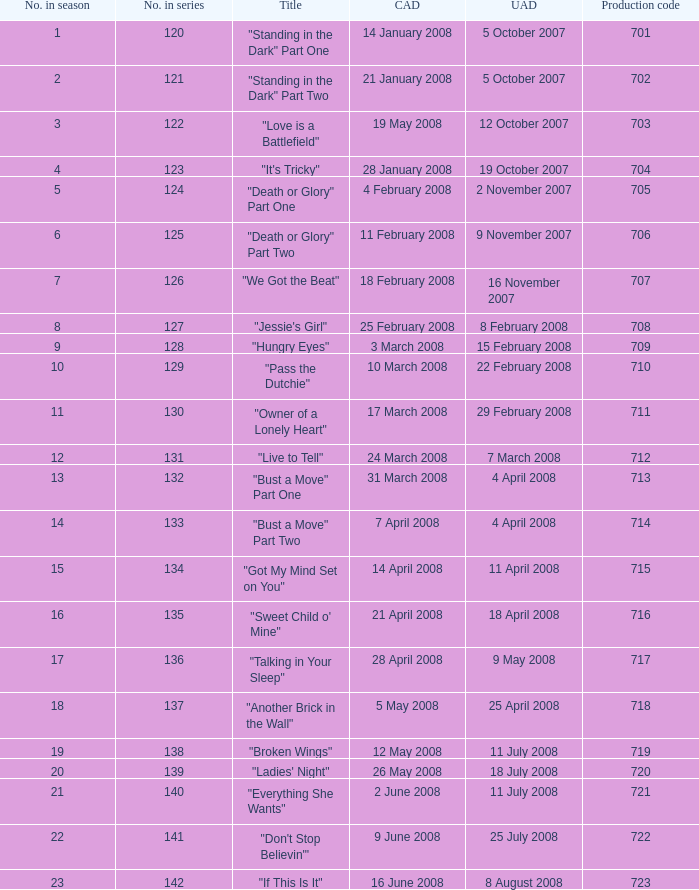The U.S. airdate of 8 august 2008 also had canadian airdates of what? 16 June 2008. 